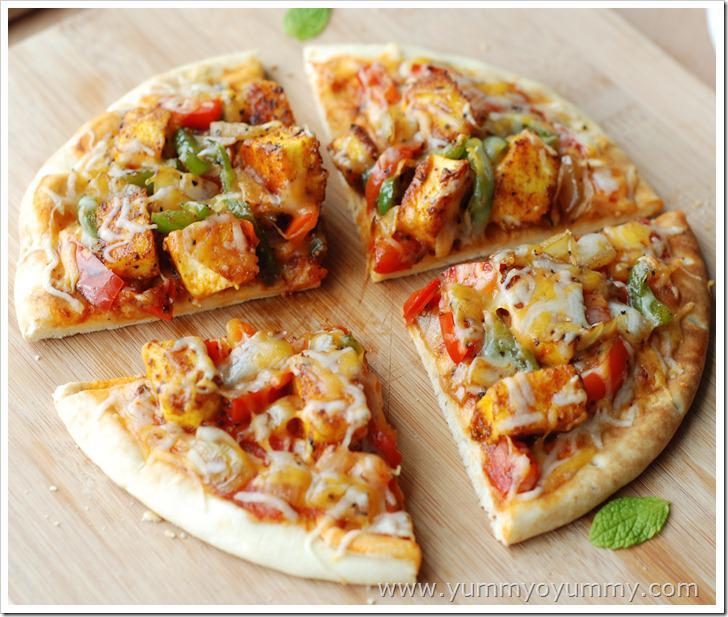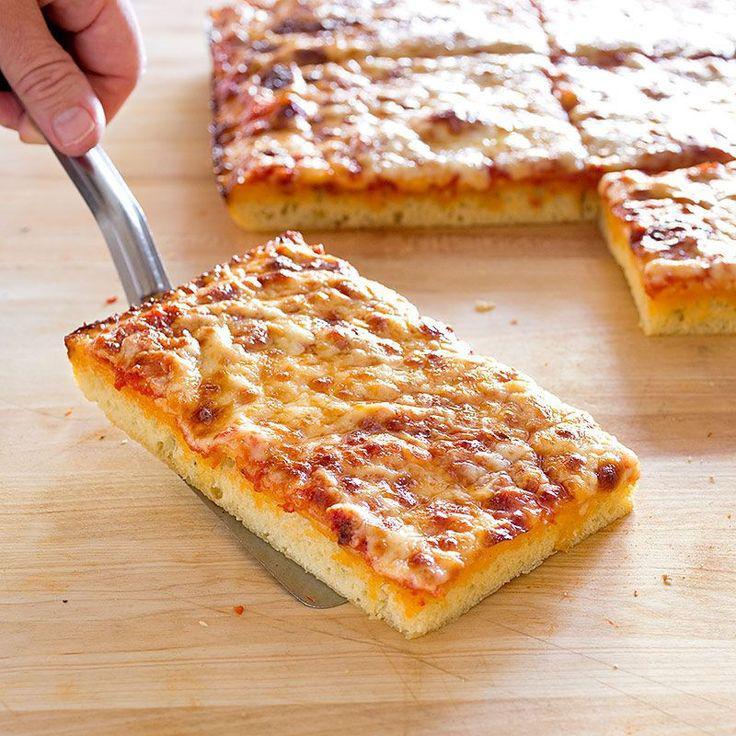The first image is the image on the left, the second image is the image on the right. Assess this claim about the two images: "All pizzas are made on pieces of bread". Correct or not? Answer yes or no. No. The first image is the image on the left, the second image is the image on the right. Considering the images on both sides, is "The left image shows a round pizza cut into slices on a wooden board, and the right image shows rectangles of pizza." valid? Answer yes or no. Yes. 